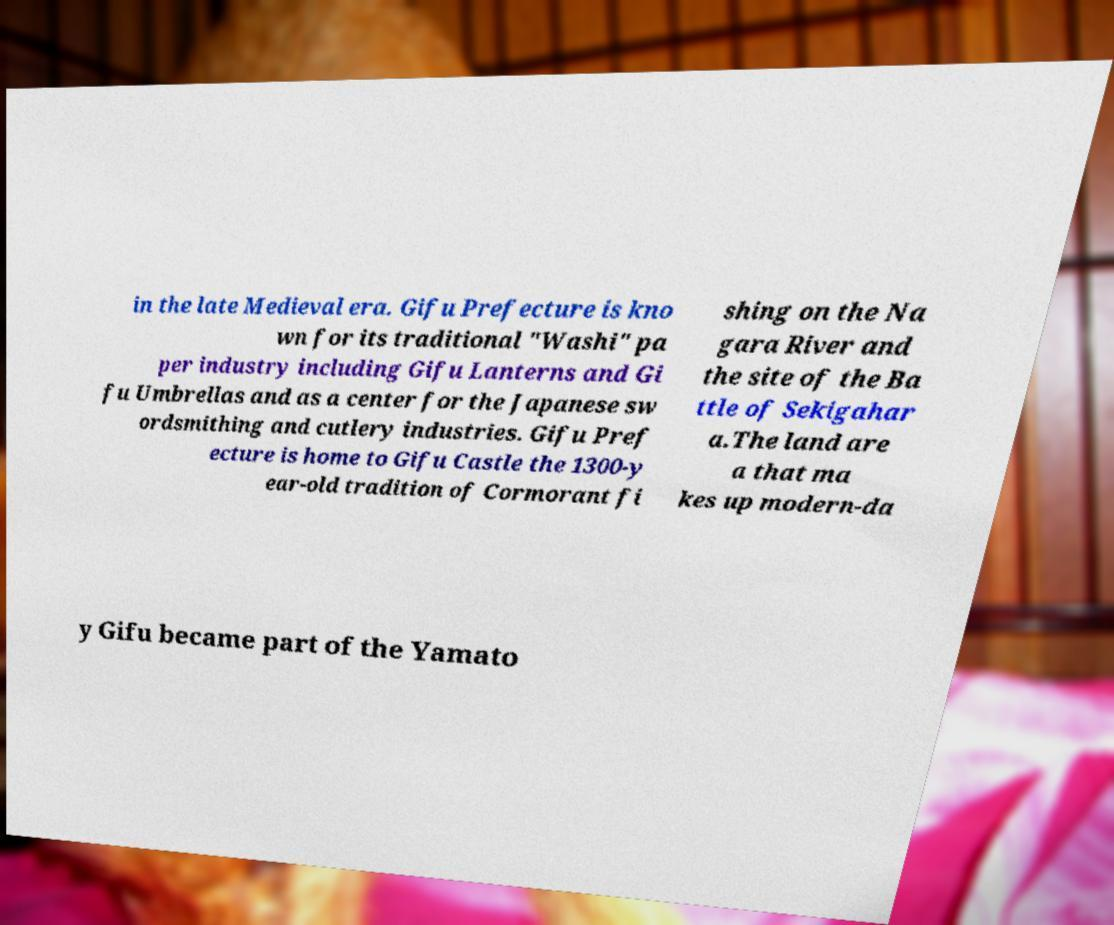Could you assist in decoding the text presented in this image and type it out clearly? in the late Medieval era. Gifu Prefecture is kno wn for its traditional "Washi" pa per industry including Gifu Lanterns and Gi fu Umbrellas and as a center for the Japanese sw ordsmithing and cutlery industries. Gifu Pref ecture is home to Gifu Castle the 1300-y ear-old tradition of Cormorant fi shing on the Na gara River and the site of the Ba ttle of Sekigahar a.The land are a that ma kes up modern-da y Gifu became part of the Yamato 